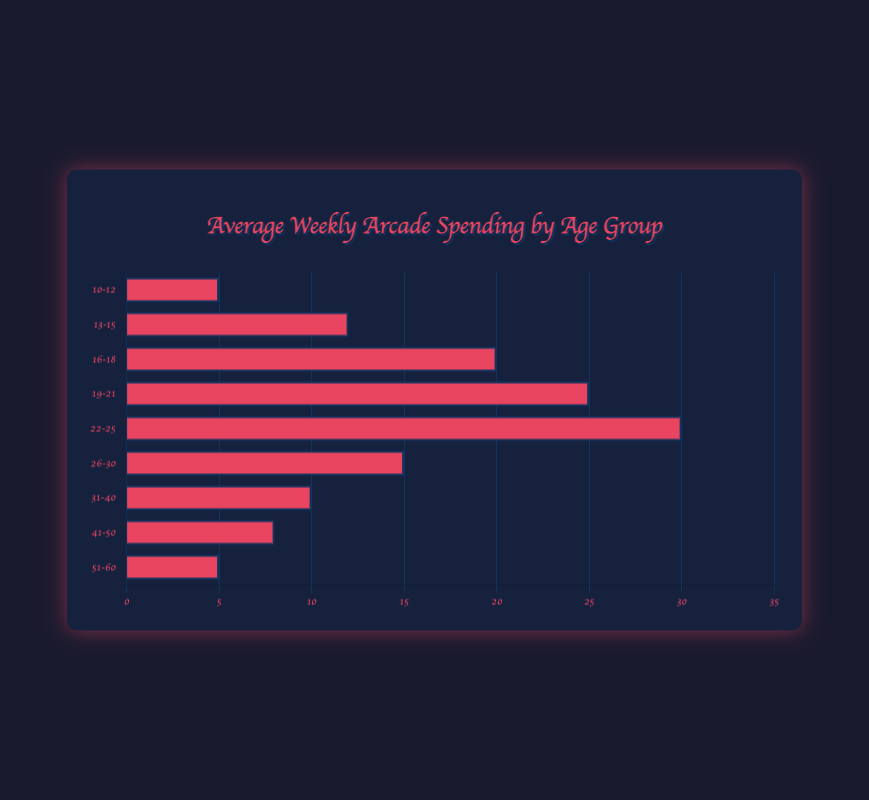Which age group spends the most on arcade games weekly? The age group with the longest bar represents the highest average spending. The "22-25" age group has the longest bar, indicating that they spend the most weekly.
Answer: 22-25 What is the average weekly spending for the 19-21 age group? Look for the bar labeled "19-21" and note its length. The label "19-21" shows an average spending of $25.
Answer: $25 How much more does the 22-25 age group spend weekly compared to the 13-15 age group? Subtract the average spending of the "13-15" group from that of the "22-25" group. It is $30 - $12.
Answer: $18 Which two age groups have the same average spending? Compare the lengths of the bars to find any that match. The "10-12" and "51-60" age groups both have bars indicating $5 in average spending.
Answer: 10-12 and 51-60 By how much does the weekly spending of the 16-18 age group exceed that of the 31-40 age group? Find the difference between the average spending amounts for the two age groups. It is $20 - $10.
Answer: $10 What's the total average weekly spending combined for age groups 19-21, 22-25, and 26-30? Add the average spending values for these groups: $25 + $30 + $15 = $70.
Answer: $70 Which age group spends less on average compared to the 31-40 age group? Identify the bars with lengths shorter than the "31-40" bar. The age groups "10-12", "41-50", and "51-60" all spend less than "31-40" which is $10.
Answer: 10-12, 41-50, 51-60 How does the average spending of the 13-15 age group compare to that of the 26-30 age group? Compare the bars of the two groups to see which is longer. The "26-30" group's bar is longer, indicating they spend more: $15 compared to $12.
Answer: 26-30 spends more What is the difference in weekly spending between the age groups 16-18 and 19-21? Subtract the average spending of the "16-18" group from that of the "19-21" group. It is $25 - $20 = $5.
Answer: $5 